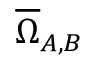<formula> <loc_0><loc_0><loc_500><loc_500>\overline { \Omega } _ { A , B }</formula> 